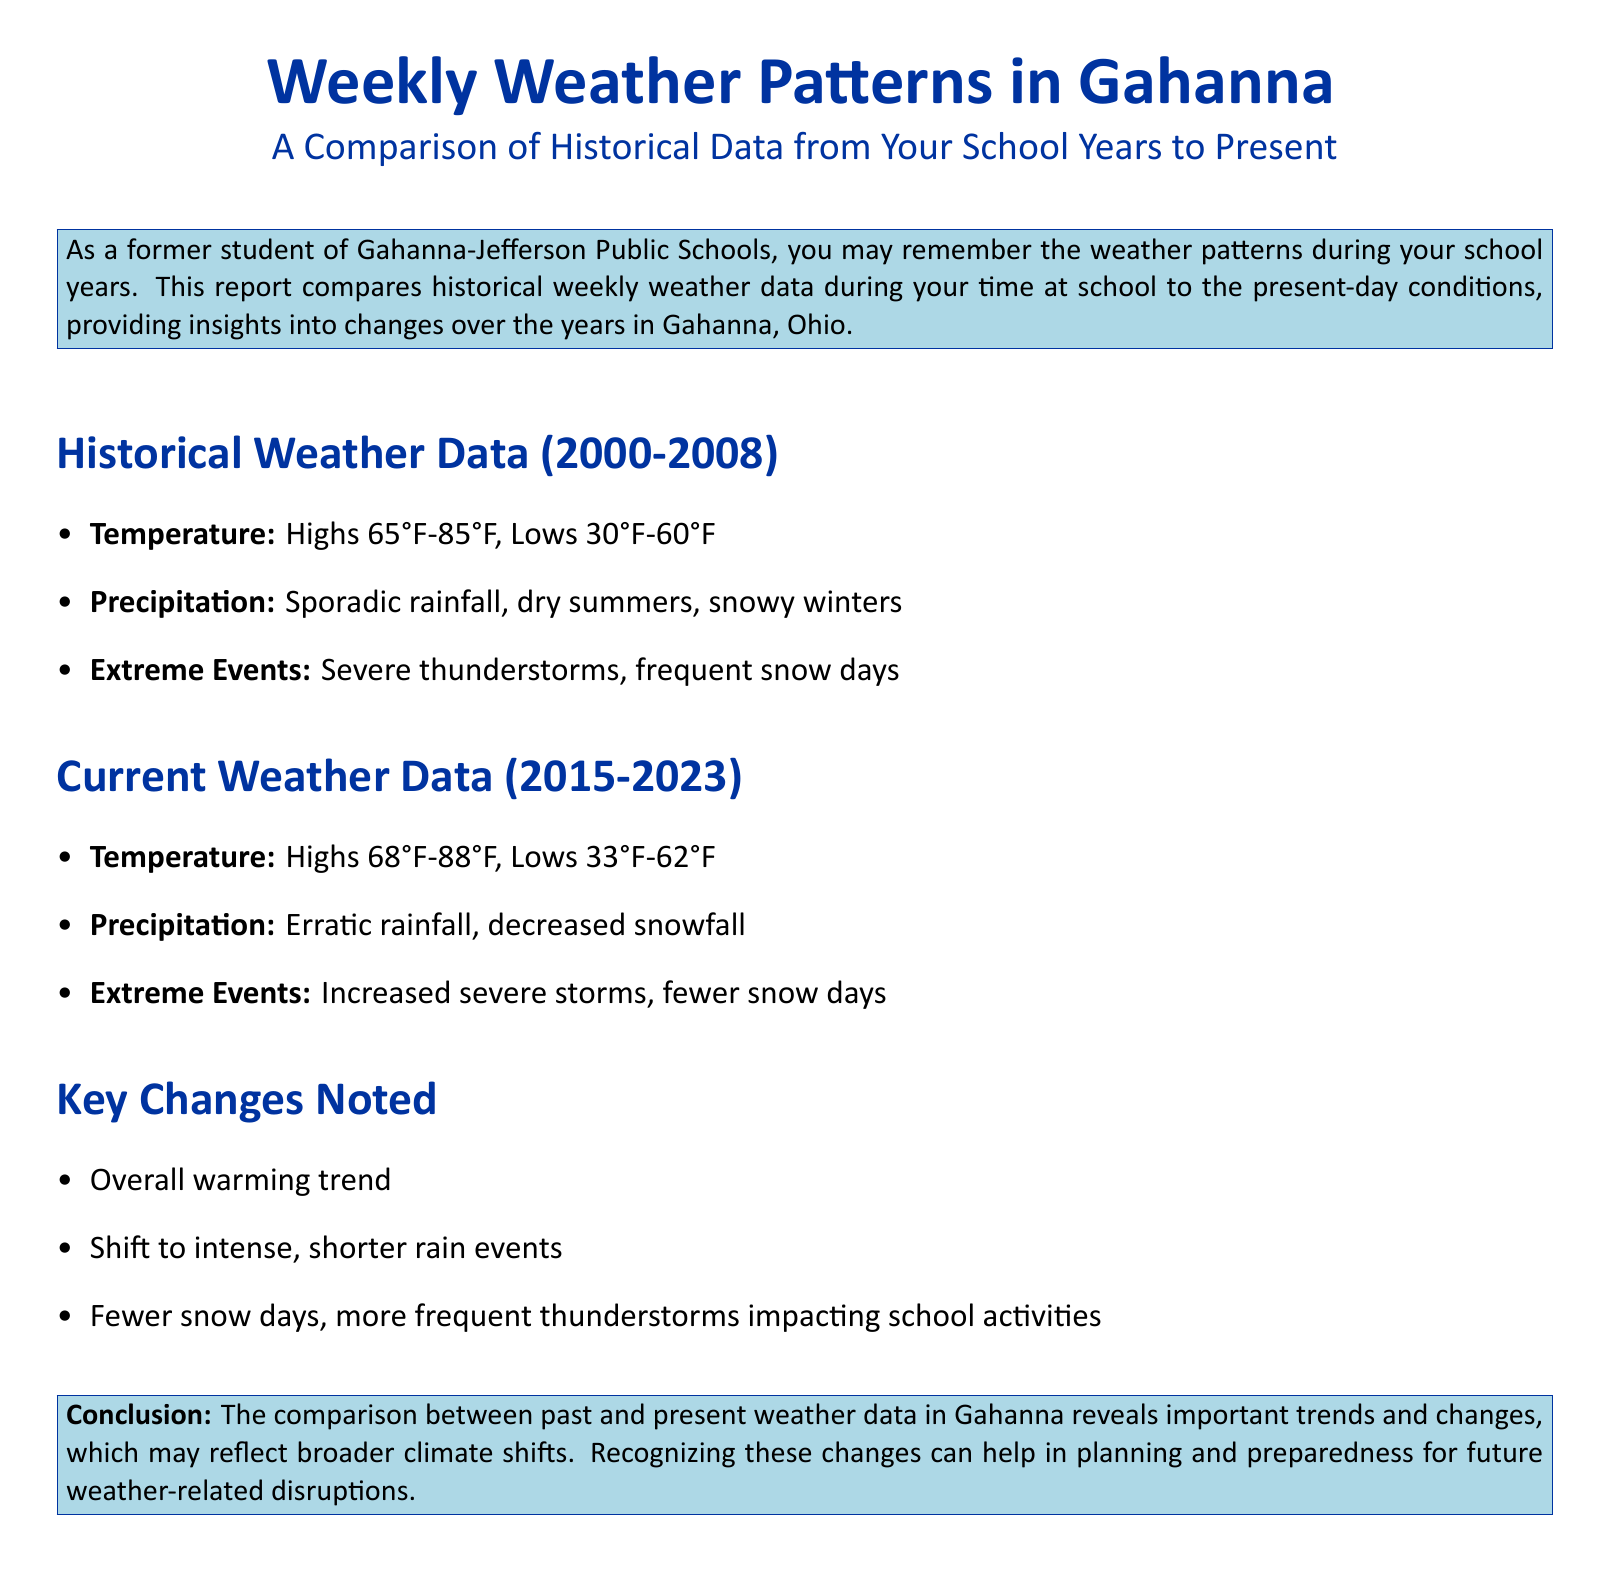What was the temperature range during the historical weather data? The historical weather data mentions temperature highs ranging from 65°F to 85°F and lows from 30°F to 60°F.
Answer: Highs 65°F-85°F, Lows 30°F-60°F What precipitation trend is noted in the current weather data? The current weather data indicates erratic rainfall and decreased snowfall.
Answer: Erratic rainfall, decreased snowfall What is a key change noted in the weather patterns? The document states several key changes, including an overall warming trend and fewer snow days.
Answer: Overall warming trend What years are included in the historical weather data? The historical data covers the period from 2000 to 2008.
Answer: 2000-2008 How many snow days were reported in the historical data? The historical weather data refers to "frequent snow days" but does not provide a specific number.
Answer: Frequent snow days 